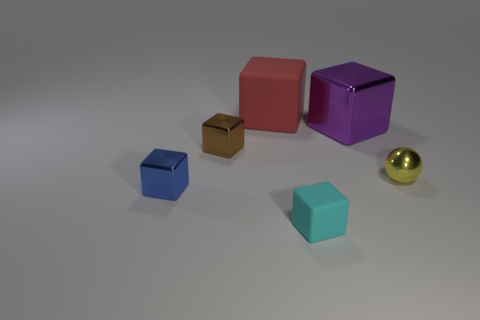What shape is the big thing that is on the right side of the rubber object that is in front of the rubber thing behind the big purple block?
Keep it short and to the point. Cube. What is the shape of the matte object that is in front of the small shiny block to the left of the brown thing?
Keep it short and to the point. Cube. Are there any blue blocks that have the same material as the brown cube?
Your answer should be compact. Yes. How many red objects are either large things or tiny rubber objects?
Give a very brief answer. 1. Is there a tiny thing of the same color as the large rubber thing?
Ensure brevity in your answer.  No. There is a red cube that is the same material as the cyan cube; what size is it?
Keep it short and to the point. Large. How many spheres are either tiny metallic things or small yellow objects?
Keep it short and to the point. 1. Is the number of big matte objects greater than the number of objects?
Provide a short and direct response. No. How many green matte blocks have the same size as the yellow shiny ball?
Your answer should be very brief. 0. What number of objects are small cubes behind the shiny sphere or purple objects?
Your answer should be very brief. 2. 